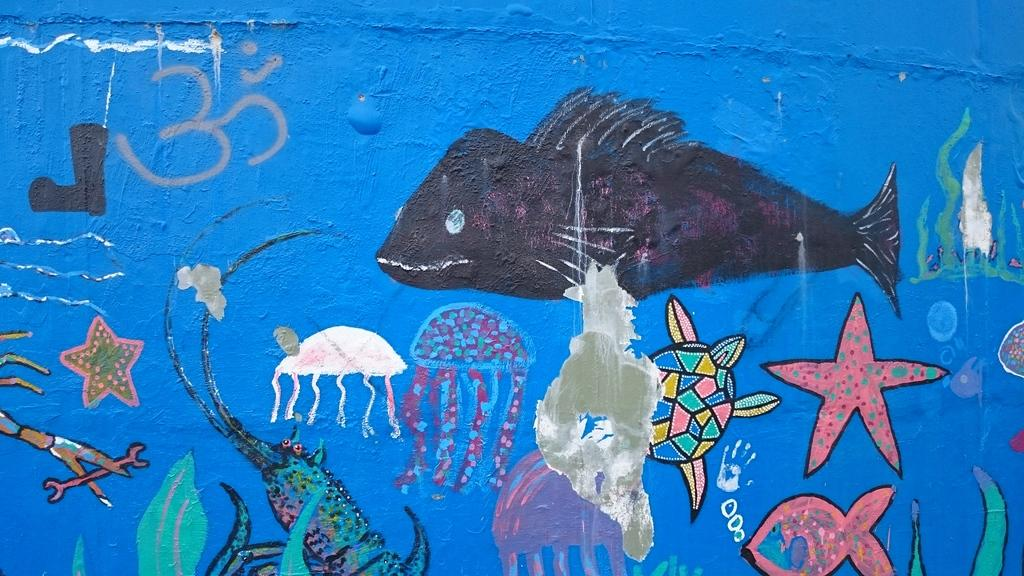What can be seen on the wall in the image? There are paintings on the wall in the image. Can you describe the paintings in any way? Unfortunately, the provided facts do not give any information about the content or style of the paintings. Are there any other decorative elements visible in the image? The given facts do not mention any other decorative elements besides the paintings on the wall. What is the title of the record playing in the background of the image? There is no mention of a record or any music playing in the image. The only information provided is about paintings on the wall. 